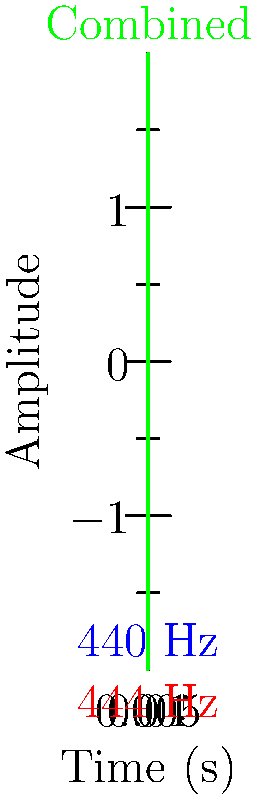As a progressive jazz musician exploring microtonal tunings, you're working with two notes: one at 440 Hz (standard A4) and another slightly sharp at 444 Hz. When played together, these notes produce a beating effect. Using the waveform diagram, calculate the beat frequency between these two notes. How might this beating effect be utilized in a jazz composition to create tension or resolution? To solve this problem, we'll follow these steps:

1) The beat frequency is the difference between the two frequencies of the notes being played simultaneously.

2) In this case, we have:
   $$f_1 = 440 \text{ Hz}$$
   $$f_2 = 444 \text{ Hz}$$

3) The beat frequency ($$f_b$$) is calculated as:
   $$f_b = |f_2 - f_1|$$

4) Substituting our values:
   $$f_b = |444 \text{ Hz} - 440 \text{ Hz}| = 4 \text{ Hz}$$

5) This means there will be 4 beats per second.

In a jazz composition, this 4 Hz beating effect could be used to create a sense of tension or instability. The pulsating sound could be employed in several ways:

- As a transitional element between sections, creating anticipation for resolution.
- To emphasize dissonance in certain chord voicings, adding depth to the harmonic texture.
- In improvisation, by deliberately playing notes that create beats with other instruments, then resolving to more consonant intervals.
- To create a rhythmic counterpoint against the main groove, adding complexity to the overall feel.

The resolution could come by either separating the pitches further (eliminating the beating) or by bringing them into unison, which would align with jazz's characteristic tension-and-release approach to harmony and rhythm.
Answer: 4 Hz 